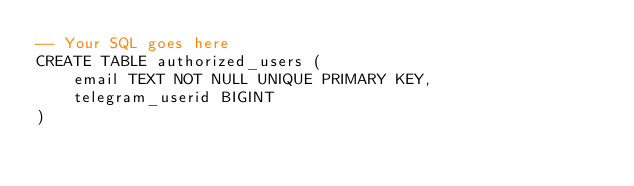Convert code to text. <code><loc_0><loc_0><loc_500><loc_500><_SQL_>-- Your SQL goes here
CREATE TABLE authorized_users (
    email TEXT NOT NULL UNIQUE PRIMARY KEY,
    telegram_userid BIGINT
)
</code> 